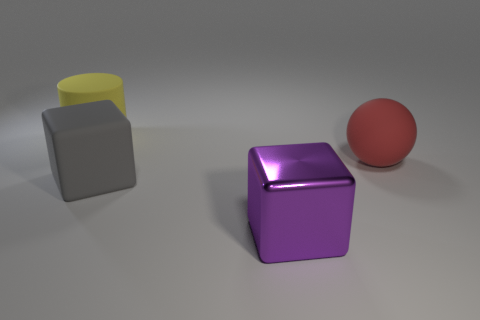Are the textures of these objects indicative of any specific material other than rubber? The objects appear to have a smooth, matte finish with soft highlights suggesting a rubbery material. There are no visible textures such as grain or fabric that would indicate the use of a material other than a synthetic rubber or plastic. 